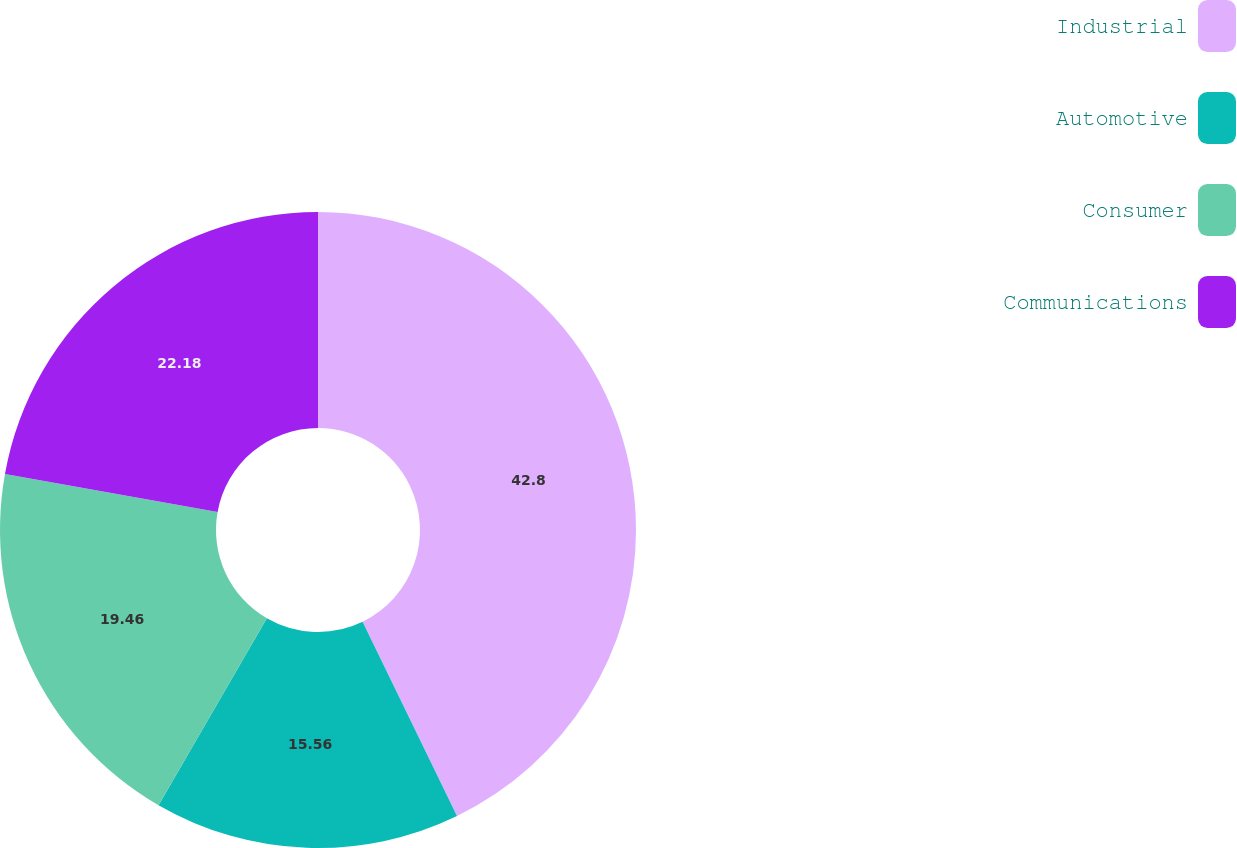Convert chart. <chart><loc_0><loc_0><loc_500><loc_500><pie_chart><fcel>Industrial<fcel>Automotive<fcel>Consumer<fcel>Communications<nl><fcel>42.8%<fcel>15.56%<fcel>19.46%<fcel>22.18%<nl></chart> 